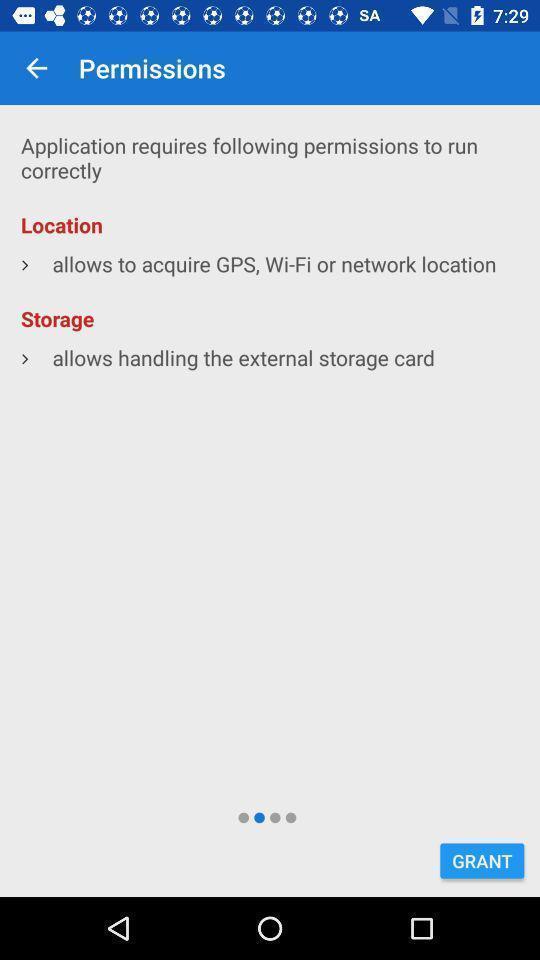Summarize the information in this screenshot. Screen displaying multiple access options in a navigation application. 